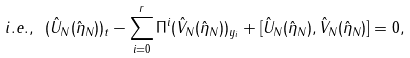<formula> <loc_0><loc_0><loc_500><loc_500>i . e . , \ ( \hat { U } _ { N } ( { \hat { \eta } _ { N } } ) ) _ { t } - \sum _ { i = 0 } ^ { r } \Pi ^ { i } ( \hat { V } _ { N } ( \hat { \eta } _ { N } ) ) _ { y _ { i } } + [ \hat { U } _ { N } ( { \hat { \eta } _ { N } } ) , \hat { V } _ { N } ( { \hat { \eta } _ { N } } ) ] = 0 ,</formula> 